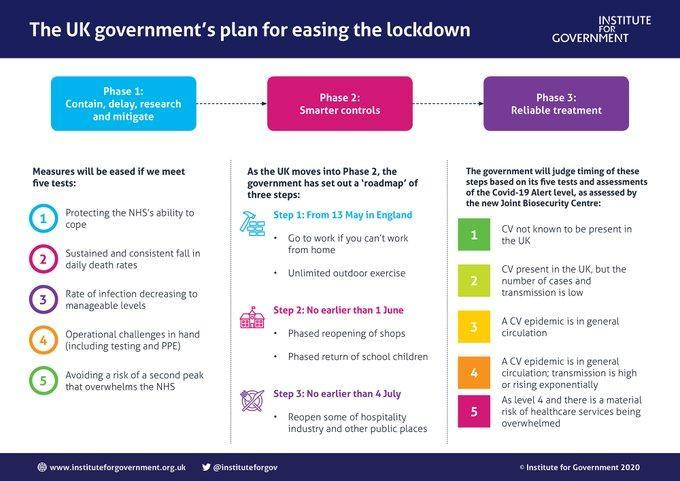How many steps are given under Phase 2?
Answer the question with a short phrase. 3 How many points are discussed under Reliable treatment? 5 